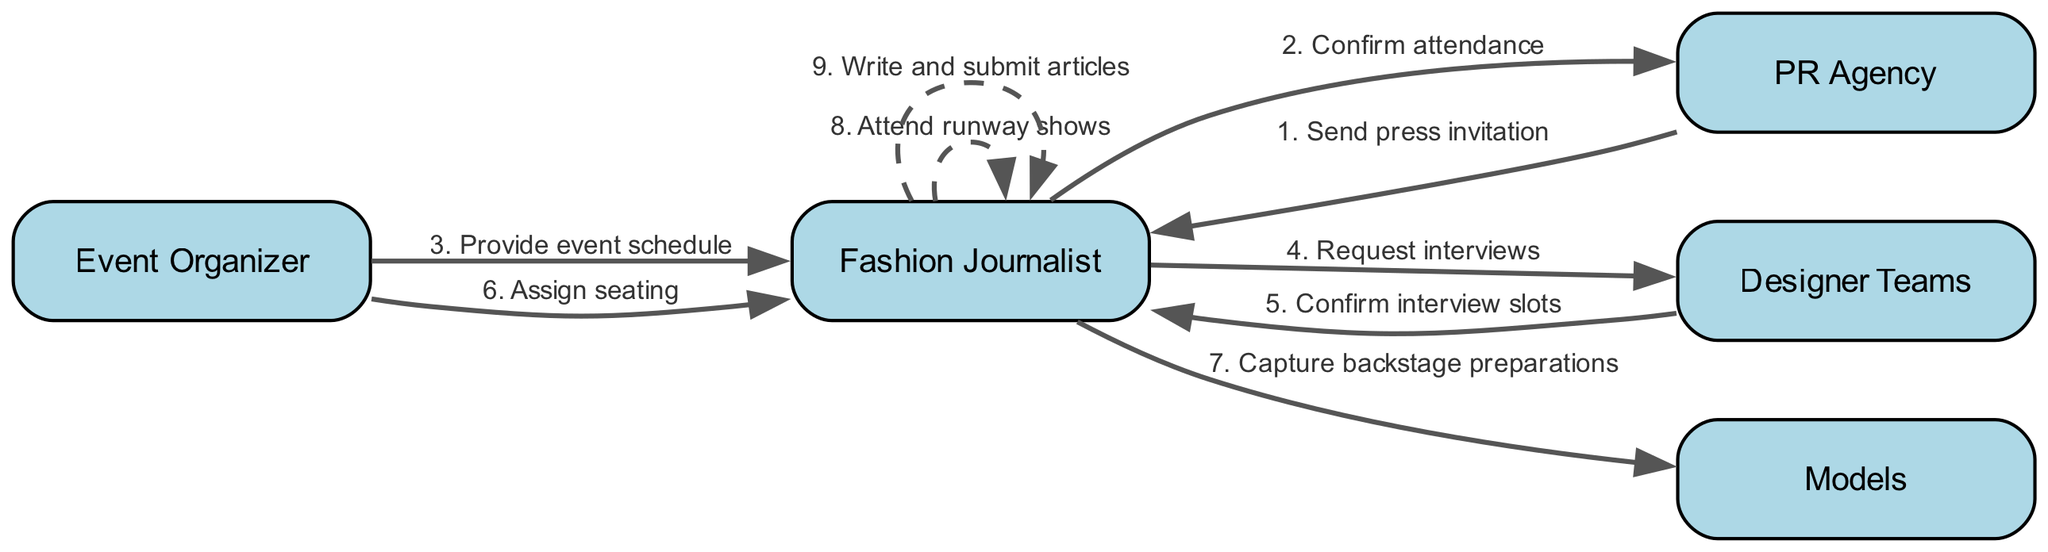What is the total number of actors in the diagram? The diagram lists five distinct actors: Fashion Journalist, PR Agency, Event Organizer, Designer Teams, and Models. Counting these gives a total of 5 actors.
Answer: 5 Which actor sends the first message? The sequence starts with the PR Agency sending a press invitation to the Fashion Journalist. Hence, the PR Agency is the actor that sends the first message.
Answer: PR Agency Who confirms the interview slots? The Designer Teams confirm the interview slots that the Fashion Journalist requests. This is shown in the sequence from Designer Teams back to Fashion Journalist.
Answer: Designer Teams What is the last action taken by the Fashion Journalist? The last action illustrated in the sequence is the Fashion Journalist writing and submitting articles. This is the final step that concludes their involvement in the event timeline.
Answer: Write and submit articles How many messages are sent from the Fashion Journalist to other actors? The Fashion Journalist sends messages to three actors: Designer Teams (request interviews), Models (capture backstage preparations), and they also have actions to themselves regarding attending runway shows and writing articles. Thus, the Fashion Journalist interacts with others through a total of three messages.
Answer: 3 What is the nature of the edge between the Fashion Journalist and itself? The edge from the Fashion Journalist to itself indicates a self-message, particularly for attending runway shows and writing articles. In this context, it is represented as a dashed line, which signifies a self-interaction or self-referential action.
Answer: Dashed line Which actor does the Event Organizer assign seating to? The Event Organizer assigns seating specifically to the Fashion Journalist, indicating that the action is directed towards this actor within the sequence.
Answer: Fashion Journalist In the sequence, who is the recipient of the event schedule? The Event Organizer provides the event schedule to the Fashion Journalist, meaning that the Fashion Journalist is the recipient of this information.
Answer: Fashion Journalist 